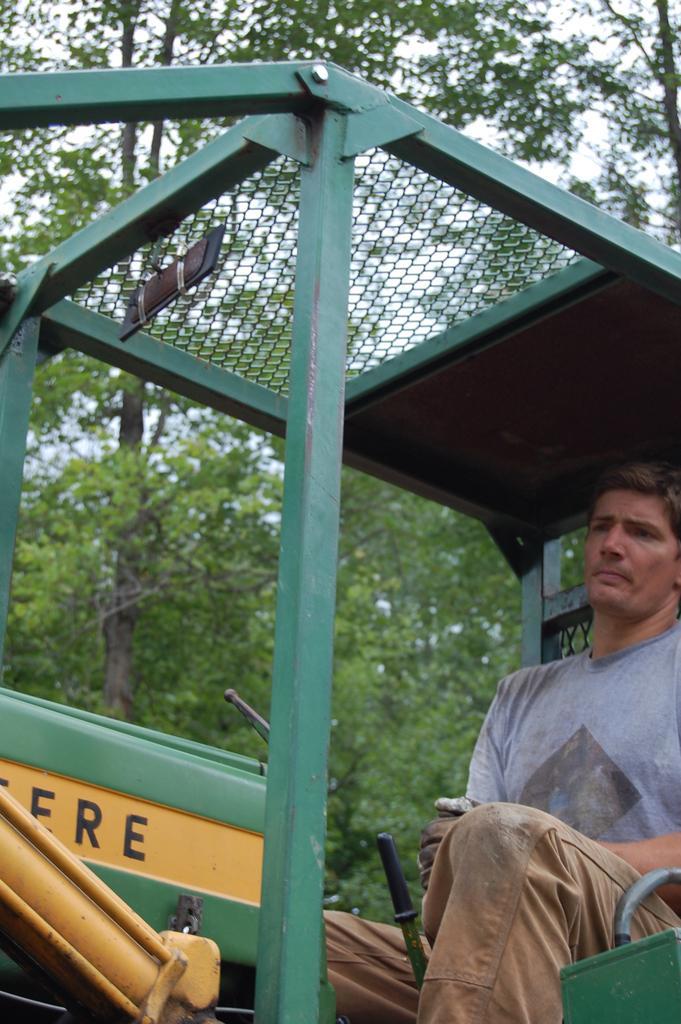How would you summarize this image in a sentence or two? In this image in front there is a person sitting on the vehicle. In the background of the image there are trees and sky. 